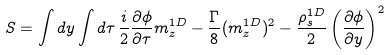<formula> <loc_0><loc_0><loc_500><loc_500>S = \int d y \int d \tau \, \frac { i } { 2 } \frac { \partial \phi } { \partial \tau } m ^ { 1 D } _ { z } - \frac { \Gamma } { 8 } ( m ^ { 1 D } _ { z } ) ^ { 2 } - \frac { \rho _ { s } ^ { 1 D } } { 2 } \left ( \frac { \partial \phi } { \partial y } \right ) ^ { 2 }</formula> 